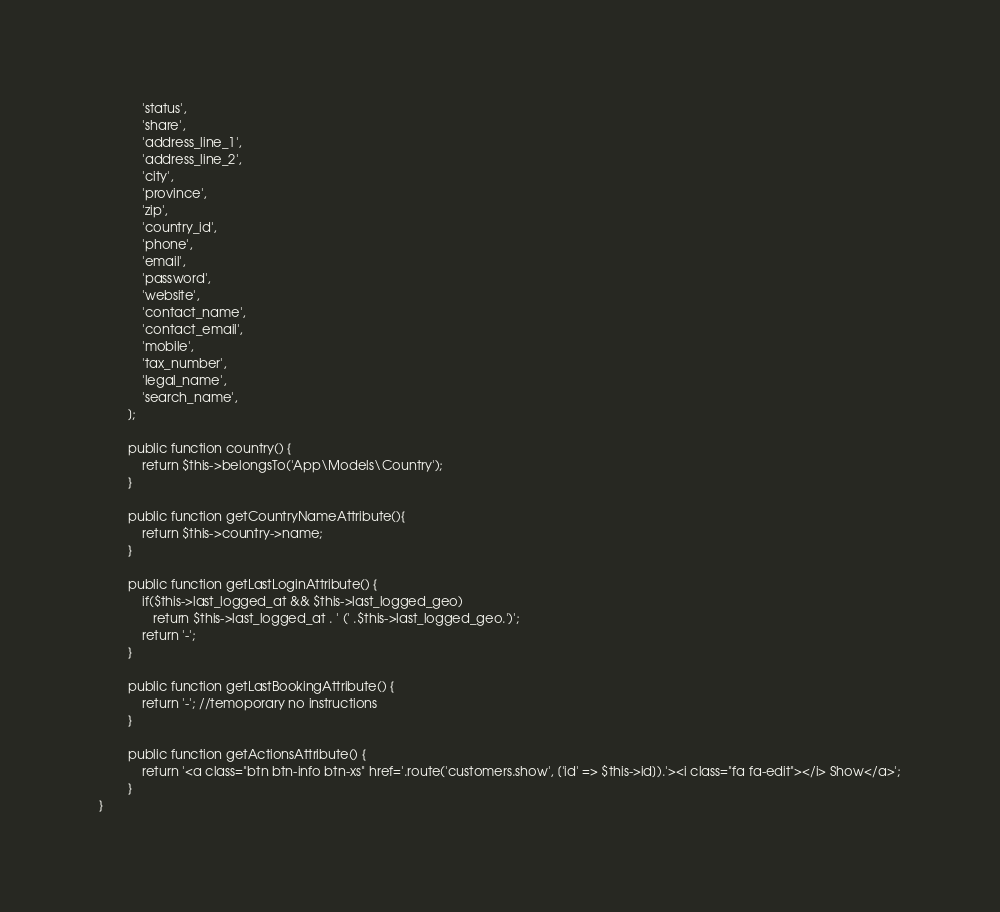<code> <loc_0><loc_0><loc_500><loc_500><_PHP_>            'status',
            'share',
            'address_line_1',
            'address_line_2',
            'city',
            'province',
            'zip',
            'country_id',
            'phone',
            'email',
            'password',
            'website',
            'contact_name',
            'contact_email',
            'mobile',
            'tax_number',
            'legal_name',
            'search_name',
        ];

        public function country() {
        	return $this->belongsTo('App\Models\Country');
        }

        public function getCountryNameAttribute(){
            return $this->country->name;
        }

        public function getLastLoginAttribute() {
            if($this->last_logged_at && $this->last_logged_geo)
               return $this->last_logged_at . ' (' .$this->last_logged_geo.')';
        	return '-';
        }

        public function getLastBookingAttribute() {
            return '-'; //temoporary no instructions
        }

        public function getActionsAttribute() {
        	return '<a class="btn btn-info btn-xs" href='.route('customers.show', ['id' => $this->id]).'><i class="fa fa-edit"></i> Show</a>';
        }
}
</code> 